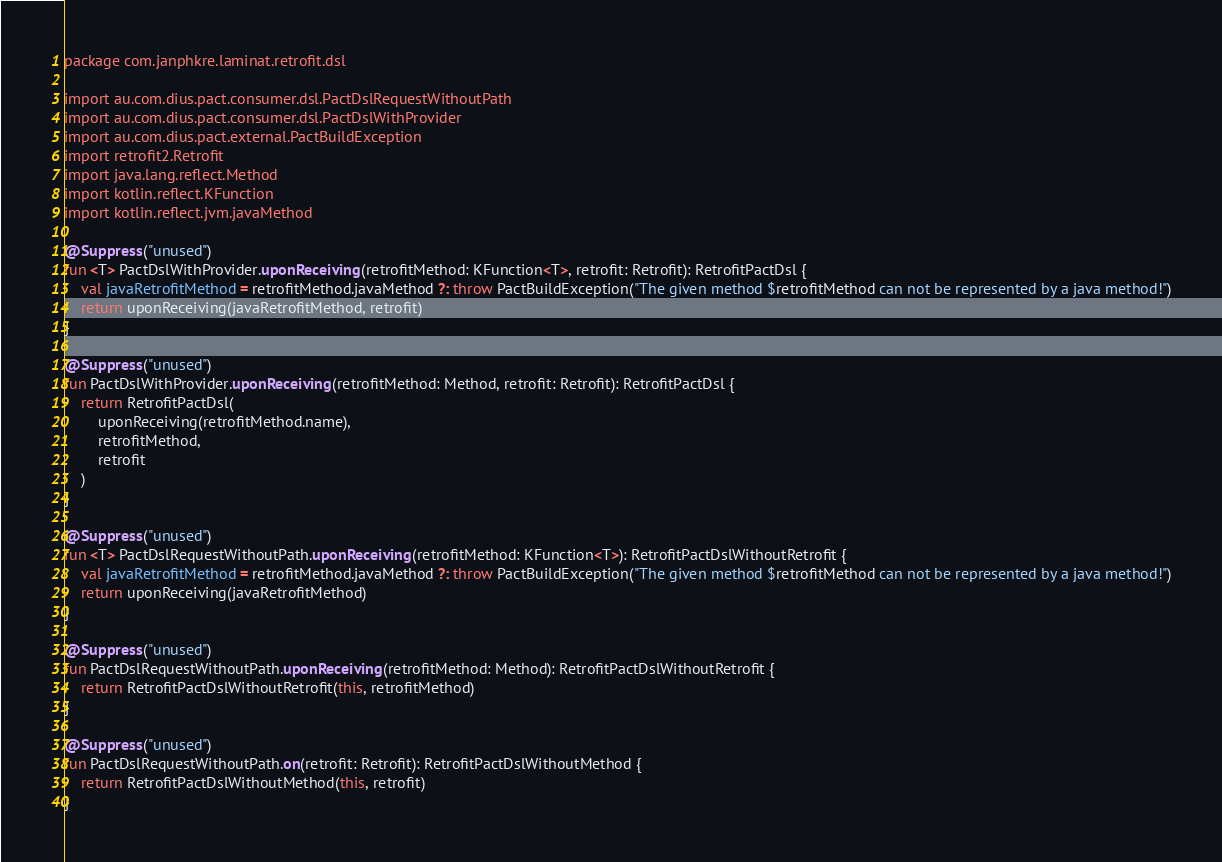Convert code to text. <code><loc_0><loc_0><loc_500><loc_500><_Kotlin_>package com.janphkre.laminat.retrofit.dsl

import au.com.dius.pact.consumer.dsl.PactDslRequestWithoutPath
import au.com.dius.pact.consumer.dsl.PactDslWithProvider
import au.com.dius.pact.external.PactBuildException
import retrofit2.Retrofit
import java.lang.reflect.Method
import kotlin.reflect.KFunction
import kotlin.reflect.jvm.javaMethod

@Suppress("unused")
fun <T> PactDslWithProvider.uponReceiving(retrofitMethod: KFunction<T>, retrofit: Retrofit): RetrofitPactDsl {
    val javaRetrofitMethod = retrofitMethod.javaMethod ?: throw PactBuildException("The given method $retrofitMethod can not be represented by a java method!")
    return uponReceiving(javaRetrofitMethod, retrofit)
}

@Suppress("unused")
fun PactDslWithProvider.uponReceiving(retrofitMethod: Method, retrofit: Retrofit): RetrofitPactDsl {
    return RetrofitPactDsl(
        uponReceiving(retrofitMethod.name),
        retrofitMethod,
        retrofit
    )
}

@Suppress("unused")
fun <T> PactDslRequestWithoutPath.uponReceiving(retrofitMethod: KFunction<T>): RetrofitPactDslWithoutRetrofit {
    val javaRetrofitMethod = retrofitMethod.javaMethod ?: throw PactBuildException("The given method $retrofitMethod can not be represented by a java method!")
    return uponReceiving(javaRetrofitMethod)
}

@Suppress("unused")
fun PactDslRequestWithoutPath.uponReceiving(retrofitMethod: Method): RetrofitPactDslWithoutRetrofit {
    return RetrofitPactDslWithoutRetrofit(this, retrofitMethod)
}

@Suppress("unused")
fun PactDslRequestWithoutPath.on(retrofit: Retrofit): RetrofitPactDslWithoutMethod {
    return RetrofitPactDslWithoutMethod(this, retrofit)
}</code> 